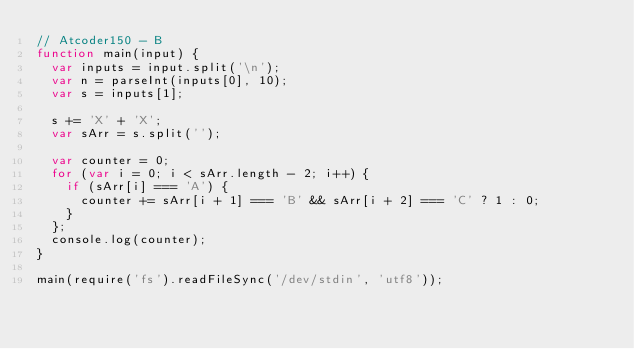Convert code to text. <code><loc_0><loc_0><loc_500><loc_500><_JavaScript_>// Atcoder150 - B
function main(input) {
  var inputs = input.split('\n');
  var n = parseInt(inputs[0], 10);
  var s = inputs[1];

  s += 'X' + 'X';
  var sArr = s.split('');

  var counter = 0;
  for (var i = 0; i < sArr.length - 2; i++) {
    if (sArr[i] === 'A') {
      counter += sArr[i + 1] === 'B' && sArr[i + 2] === 'C' ? 1 : 0;
    }
  };
  console.log(counter);
}

main(require('fs').readFileSync('/dev/stdin', 'utf8'));
</code> 